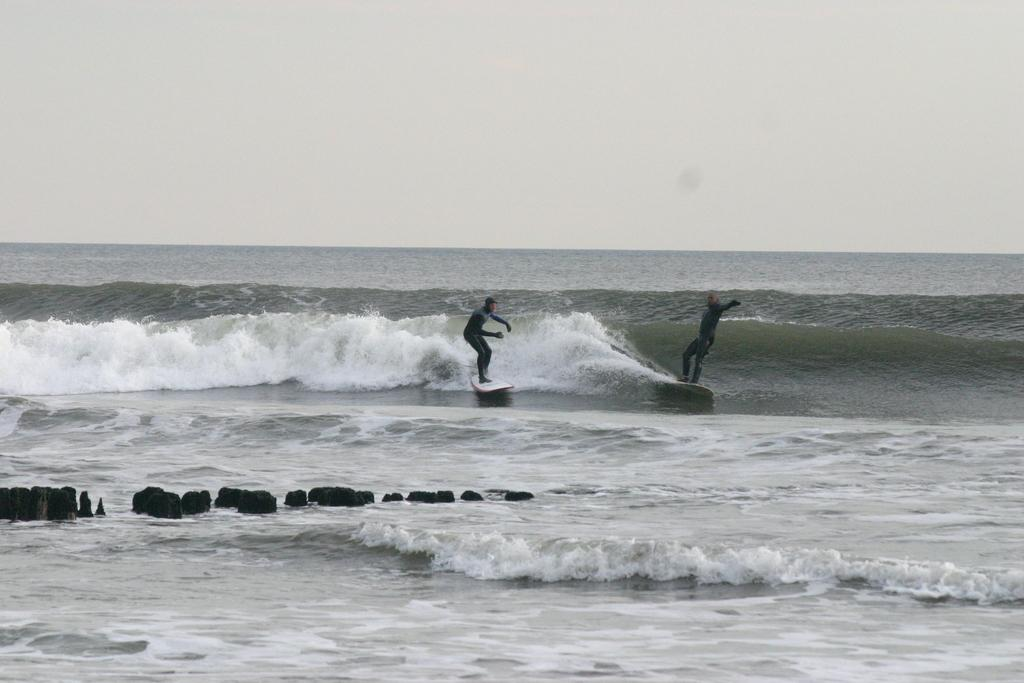How many people are in the image? There are two people in the image. What are the people doing in the image? The people are on surfboards. What else can be seen in the image besides the people? There are objects visible in the image. What is the condition of the water in the image? Waves are visible in the water. What is visible at the top of the image? The sky is visible at the top of the image. Can you tell me how many bees are buzzing around the goose in the image? There are no bees or geese present in the image; it features two people on surfboards in the water. 